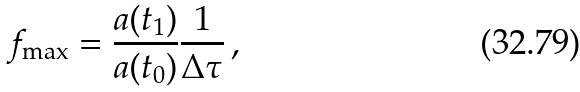Convert formula to latex. <formula><loc_0><loc_0><loc_500><loc_500>f _ { \max } = \frac { a ( t _ { 1 } ) } { a ( t _ { 0 } ) } \frac { 1 } { \Delta \tau } \, ,</formula> 